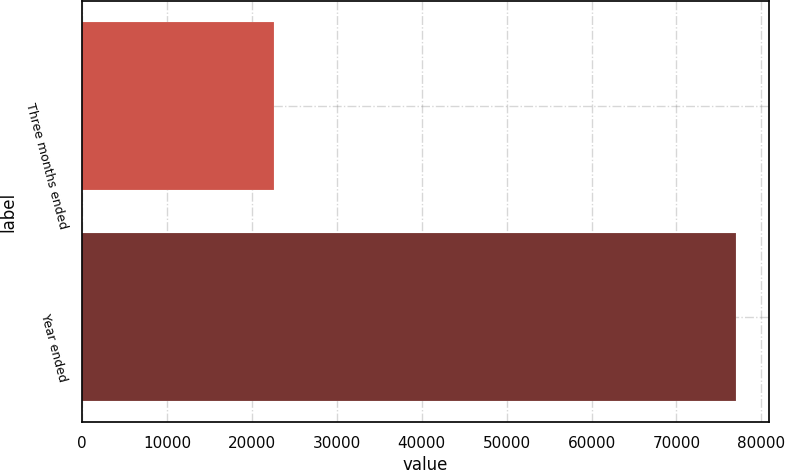Convert chart to OTSL. <chart><loc_0><loc_0><loc_500><loc_500><bar_chart><fcel>Three months ended<fcel>Year ended<nl><fcel>22615<fcel>77062<nl></chart> 